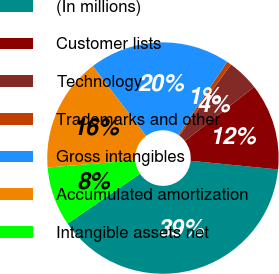<chart> <loc_0><loc_0><loc_500><loc_500><pie_chart><fcel>(In millions)<fcel>Customer lists<fcel>Technology<fcel>Trademarks and other<fcel>Gross intangibles<fcel>Accumulated amortization<fcel>Intangible assets net<nl><fcel>38.85%<fcel>12.1%<fcel>4.46%<fcel>0.64%<fcel>19.74%<fcel>15.92%<fcel>8.28%<nl></chart> 